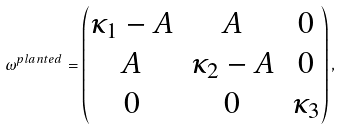Convert formula to latex. <formula><loc_0><loc_0><loc_500><loc_500>\omega ^ { p l a n t e d } = \begin{pmatrix} \kappa _ { 1 } - A & A & 0 \\ A & \kappa _ { 2 } - A & 0 \\ 0 & 0 & \kappa _ { 3 } \end{pmatrix} ,</formula> 